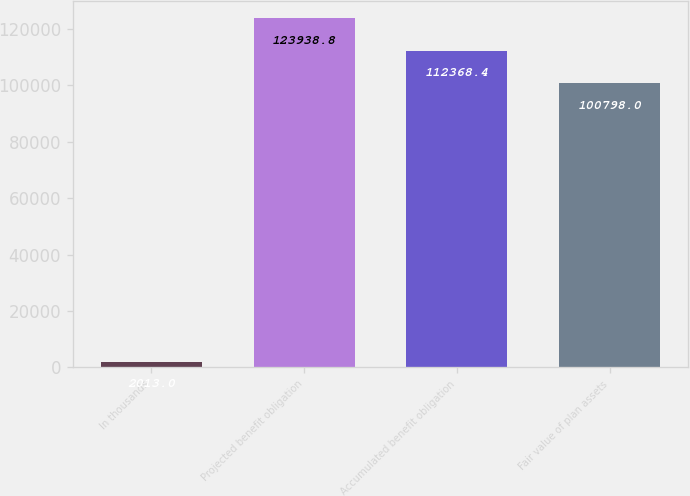<chart> <loc_0><loc_0><loc_500><loc_500><bar_chart><fcel>In thousands<fcel>Projected benefit obligation<fcel>Accumulated benefit obligation<fcel>Fair value of plan assets<nl><fcel>2013<fcel>123939<fcel>112368<fcel>100798<nl></chart> 